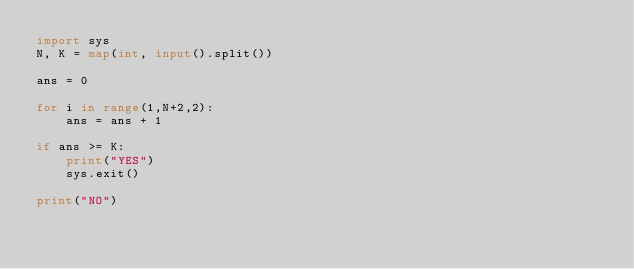Convert code to text. <code><loc_0><loc_0><loc_500><loc_500><_Python_>import sys
N, K = map(int, input().split())

ans = 0

for i in range(1,N+2,2):
    ans = ans + 1

if ans >= K:
    print("YES")
    sys.exit()

print("NO")</code> 